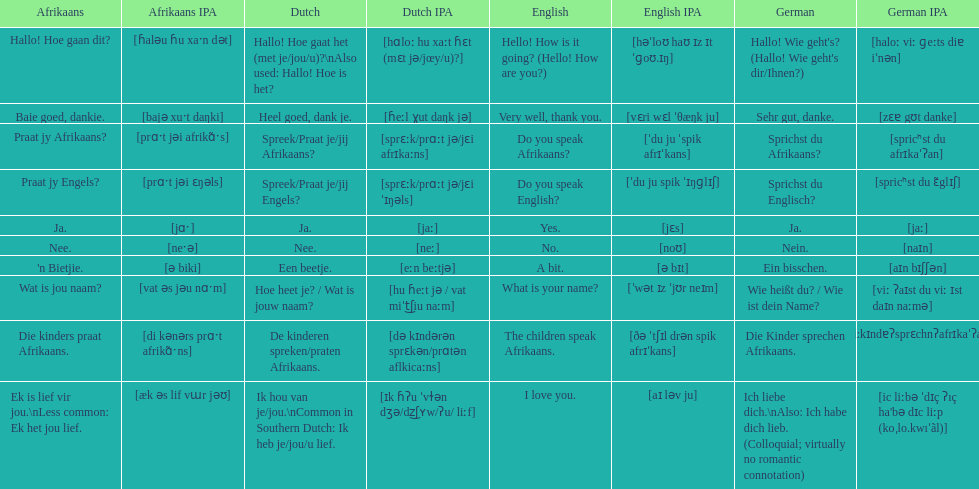Translate the following into german: die kinders praat afrikaans. Die Kinder sprechen Afrikaans. 